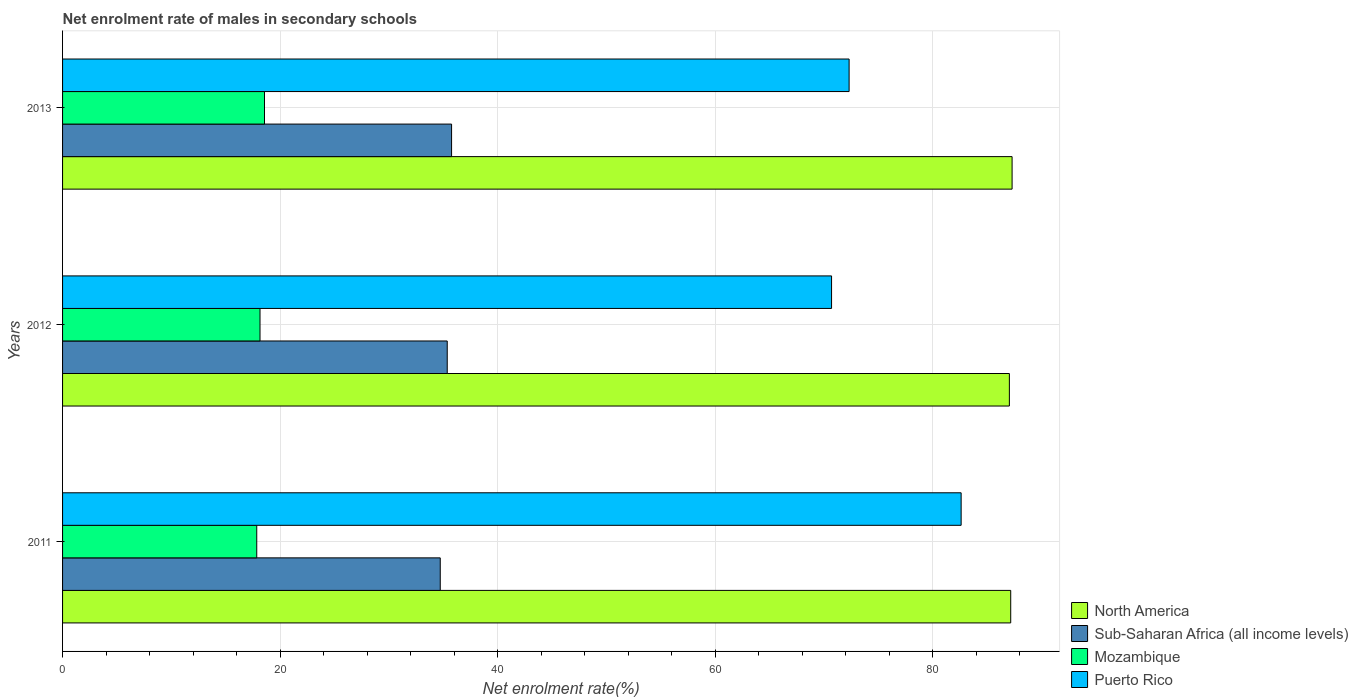Are the number of bars per tick equal to the number of legend labels?
Give a very brief answer. Yes. Are the number of bars on each tick of the Y-axis equal?
Make the answer very short. Yes. How many bars are there on the 2nd tick from the top?
Your response must be concise. 4. How many bars are there on the 3rd tick from the bottom?
Offer a very short reply. 4. In how many cases, is the number of bars for a given year not equal to the number of legend labels?
Your answer should be compact. 0. What is the net enrolment rate of males in secondary schools in Puerto Rico in 2013?
Keep it short and to the point. 72.31. Across all years, what is the maximum net enrolment rate of males in secondary schools in Sub-Saharan Africa (all income levels)?
Give a very brief answer. 35.76. Across all years, what is the minimum net enrolment rate of males in secondary schools in North America?
Keep it short and to the point. 87.04. What is the total net enrolment rate of males in secondary schools in Puerto Rico in the graph?
Keep it short and to the point. 225.6. What is the difference between the net enrolment rate of males in secondary schools in Puerto Rico in 2011 and that in 2012?
Make the answer very short. 11.91. What is the difference between the net enrolment rate of males in secondary schools in Mozambique in 2013 and the net enrolment rate of males in secondary schools in North America in 2012?
Your answer should be compact. -68.47. What is the average net enrolment rate of males in secondary schools in Sub-Saharan Africa (all income levels) per year?
Your answer should be compact. 35.28. In the year 2013, what is the difference between the net enrolment rate of males in secondary schools in North America and net enrolment rate of males in secondary schools in Mozambique?
Offer a terse response. 68.72. In how many years, is the net enrolment rate of males in secondary schools in North America greater than 8 %?
Keep it short and to the point. 3. What is the ratio of the net enrolment rate of males in secondary schools in North America in 2011 to that in 2013?
Your response must be concise. 1. Is the net enrolment rate of males in secondary schools in Puerto Rico in 2012 less than that in 2013?
Ensure brevity in your answer.  Yes. Is the difference between the net enrolment rate of males in secondary schools in North America in 2011 and 2013 greater than the difference between the net enrolment rate of males in secondary schools in Mozambique in 2011 and 2013?
Offer a very short reply. Yes. What is the difference between the highest and the second highest net enrolment rate of males in secondary schools in Sub-Saharan Africa (all income levels)?
Make the answer very short. 0.4. What is the difference between the highest and the lowest net enrolment rate of males in secondary schools in Mozambique?
Provide a succinct answer. 0.71. In how many years, is the net enrolment rate of males in secondary schools in North America greater than the average net enrolment rate of males in secondary schools in North America taken over all years?
Make the answer very short. 1. Is it the case that in every year, the sum of the net enrolment rate of males in secondary schools in Sub-Saharan Africa (all income levels) and net enrolment rate of males in secondary schools in North America is greater than the sum of net enrolment rate of males in secondary schools in Mozambique and net enrolment rate of males in secondary schools in Puerto Rico?
Provide a short and direct response. Yes. What does the 3rd bar from the top in 2012 represents?
Give a very brief answer. Sub-Saharan Africa (all income levels). What does the 4th bar from the bottom in 2011 represents?
Offer a very short reply. Puerto Rico. Are all the bars in the graph horizontal?
Your response must be concise. Yes. Are the values on the major ticks of X-axis written in scientific E-notation?
Offer a terse response. No. Does the graph contain any zero values?
Provide a succinct answer. No. Does the graph contain grids?
Give a very brief answer. Yes. How are the legend labels stacked?
Your answer should be compact. Vertical. What is the title of the graph?
Your answer should be very brief. Net enrolment rate of males in secondary schools. What is the label or title of the X-axis?
Keep it short and to the point. Net enrolment rate(%). What is the label or title of the Y-axis?
Offer a very short reply. Years. What is the Net enrolment rate(%) of North America in 2011?
Ensure brevity in your answer.  87.16. What is the Net enrolment rate(%) of Sub-Saharan Africa (all income levels) in 2011?
Your answer should be very brief. 34.72. What is the Net enrolment rate(%) in Mozambique in 2011?
Provide a short and direct response. 17.85. What is the Net enrolment rate(%) of Puerto Rico in 2011?
Offer a terse response. 82.6. What is the Net enrolment rate(%) in North America in 2012?
Your response must be concise. 87.04. What is the Net enrolment rate(%) in Sub-Saharan Africa (all income levels) in 2012?
Keep it short and to the point. 35.36. What is the Net enrolment rate(%) in Mozambique in 2012?
Offer a terse response. 18.15. What is the Net enrolment rate(%) in Puerto Rico in 2012?
Offer a terse response. 70.69. What is the Net enrolment rate(%) of North America in 2013?
Make the answer very short. 87.29. What is the Net enrolment rate(%) of Sub-Saharan Africa (all income levels) in 2013?
Your response must be concise. 35.76. What is the Net enrolment rate(%) in Mozambique in 2013?
Keep it short and to the point. 18.56. What is the Net enrolment rate(%) of Puerto Rico in 2013?
Your response must be concise. 72.31. Across all years, what is the maximum Net enrolment rate(%) of North America?
Provide a short and direct response. 87.29. Across all years, what is the maximum Net enrolment rate(%) of Sub-Saharan Africa (all income levels)?
Your response must be concise. 35.76. Across all years, what is the maximum Net enrolment rate(%) in Mozambique?
Your answer should be very brief. 18.56. Across all years, what is the maximum Net enrolment rate(%) in Puerto Rico?
Provide a succinct answer. 82.6. Across all years, what is the minimum Net enrolment rate(%) of North America?
Your response must be concise. 87.04. Across all years, what is the minimum Net enrolment rate(%) in Sub-Saharan Africa (all income levels)?
Provide a succinct answer. 34.72. Across all years, what is the minimum Net enrolment rate(%) in Mozambique?
Your answer should be compact. 17.85. Across all years, what is the minimum Net enrolment rate(%) of Puerto Rico?
Offer a terse response. 70.69. What is the total Net enrolment rate(%) of North America in the graph?
Your answer should be compact. 261.49. What is the total Net enrolment rate(%) of Sub-Saharan Africa (all income levels) in the graph?
Offer a very short reply. 105.84. What is the total Net enrolment rate(%) of Mozambique in the graph?
Provide a succinct answer. 54.57. What is the total Net enrolment rate(%) of Puerto Rico in the graph?
Keep it short and to the point. 225.6. What is the difference between the Net enrolment rate(%) of North America in 2011 and that in 2012?
Your response must be concise. 0.12. What is the difference between the Net enrolment rate(%) in Sub-Saharan Africa (all income levels) in 2011 and that in 2012?
Your response must be concise. -0.64. What is the difference between the Net enrolment rate(%) of Mozambique in 2011 and that in 2012?
Offer a very short reply. -0.3. What is the difference between the Net enrolment rate(%) in Puerto Rico in 2011 and that in 2012?
Your answer should be very brief. 11.91. What is the difference between the Net enrolment rate(%) in North America in 2011 and that in 2013?
Your answer should be compact. -0.13. What is the difference between the Net enrolment rate(%) of Sub-Saharan Africa (all income levels) in 2011 and that in 2013?
Your answer should be compact. -1.04. What is the difference between the Net enrolment rate(%) in Mozambique in 2011 and that in 2013?
Give a very brief answer. -0.71. What is the difference between the Net enrolment rate(%) in Puerto Rico in 2011 and that in 2013?
Keep it short and to the point. 10.3. What is the difference between the Net enrolment rate(%) of North America in 2012 and that in 2013?
Provide a succinct answer. -0.25. What is the difference between the Net enrolment rate(%) of Sub-Saharan Africa (all income levels) in 2012 and that in 2013?
Make the answer very short. -0.4. What is the difference between the Net enrolment rate(%) of Mozambique in 2012 and that in 2013?
Keep it short and to the point. -0.41. What is the difference between the Net enrolment rate(%) of Puerto Rico in 2012 and that in 2013?
Your answer should be very brief. -1.61. What is the difference between the Net enrolment rate(%) in North America in 2011 and the Net enrolment rate(%) in Sub-Saharan Africa (all income levels) in 2012?
Your response must be concise. 51.8. What is the difference between the Net enrolment rate(%) of North America in 2011 and the Net enrolment rate(%) of Mozambique in 2012?
Make the answer very short. 69.01. What is the difference between the Net enrolment rate(%) of North America in 2011 and the Net enrolment rate(%) of Puerto Rico in 2012?
Offer a very short reply. 16.47. What is the difference between the Net enrolment rate(%) in Sub-Saharan Africa (all income levels) in 2011 and the Net enrolment rate(%) in Mozambique in 2012?
Give a very brief answer. 16.57. What is the difference between the Net enrolment rate(%) in Sub-Saharan Africa (all income levels) in 2011 and the Net enrolment rate(%) in Puerto Rico in 2012?
Keep it short and to the point. -35.97. What is the difference between the Net enrolment rate(%) in Mozambique in 2011 and the Net enrolment rate(%) in Puerto Rico in 2012?
Provide a short and direct response. -52.84. What is the difference between the Net enrolment rate(%) of North America in 2011 and the Net enrolment rate(%) of Sub-Saharan Africa (all income levels) in 2013?
Provide a succinct answer. 51.4. What is the difference between the Net enrolment rate(%) in North America in 2011 and the Net enrolment rate(%) in Mozambique in 2013?
Ensure brevity in your answer.  68.6. What is the difference between the Net enrolment rate(%) of North America in 2011 and the Net enrolment rate(%) of Puerto Rico in 2013?
Your response must be concise. 14.86. What is the difference between the Net enrolment rate(%) in Sub-Saharan Africa (all income levels) in 2011 and the Net enrolment rate(%) in Mozambique in 2013?
Your answer should be very brief. 16.16. What is the difference between the Net enrolment rate(%) of Sub-Saharan Africa (all income levels) in 2011 and the Net enrolment rate(%) of Puerto Rico in 2013?
Your response must be concise. -37.59. What is the difference between the Net enrolment rate(%) in Mozambique in 2011 and the Net enrolment rate(%) in Puerto Rico in 2013?
Provide a succinct answer. -54.45. What is the difference between the Net enrolment rate(%) in North America in 2012 and the Net enrolment rate(%) in Sub-Saharan Africa (all income levels) in 2013?
Make the answer very short. 51.28. What is the difference between the Net enrolment rate(%) of North America in 2012 and the Net enrolment rate(%) of Mozambique in 2013?
Provide a short and direct response. 68.47. What is the difference between the Net enrolment rate(%) of North America in 2012 and the Net enrolment rate(%) of Puerto Rico in 2013?
Offer a terse response. 14.73. What is the difference between the Net enrolment rate(%) of Sub-Saharan Africa (all income levels) in 2012 and the Net enrolment rate(%) of Mozambique in 2013?
Your answer should be very brief. 16.8. What is the difference between the Net enrolment rate(%) of Sub-Saharan Africa (all income levels) in 2012 and the Net enrolment rate(%) of Puerto Rico in 2013?
Ensure brevity in your answer.  -36.94. What is the difference between the Net enrolment rate(%) of Mozambique in 2012 and the Net enrolment rate(%) of Puerto Rico in 2013?
Provide a succinct answer. -54.15. What is the average Net enrolment rate(%) in North America per year?
Ensure brevity in your answer.  87.16. What is the average Net enrolment rate(%) in Sub-Saharan Africa (all income levels) per year?
Your answer should be compact. 35.28. What is the average Net enrolment rate(%) of Mozambique per year?
Offer a terse response. 18.19. What is the average Net enrolment rate(%) in Puerto Rico per year?
Provide a short and direct response. 75.2. In the year 2011, what is the difference between the Net enrolment rate(%) in North America and Net enrolment rate(%) in Sub-Saharan Africa (all income levels)?
Make the answer very short. 52.44. In the year 2011, what is the difference between the Net enrolment rate(%) in North America and Net enrolment rate(%) in Mozambique?
Your answer should be very brief. 69.31. In the year 2011, what is the difference between the Net enrolment rate(%) in North America and Net enrolment rate(%) in Puerto Rico?
Offer a very short reply. 4.56. In the year 2011, what is the difference between the Net enrolment rate(%) of Sub-Saharan Africa (all income levels) and Net enrolment rate(%) of Mozambique?
Your answer should be compact. 16.87. In the year 2011, what is the difference between the Net enrolment rate(%) of Sub-Saharan Africa (all income levels) and Net enrolment rate(%) of Puerto Rico?
Provide a succinct answer. -47.88. In the year 2011, what is the difference between the Net enrolment rate(%) in Mozambique and Net enrolment rate(%) in Puerto Rico?
Provide a succinct answer. -64.75. In the year 2012, what is the difference between the Net enrolment rate(%) of North America and Net enrolment rate(%) of Sub-Saharan Africa (all income levels)?
Your answer should be very brief. 51.68. In the year 2012, what is the difference between the Net enrolment rate(%) in North America and Net enrolment rate(%) in Mozambique?
Make the answer very short. 68.89. In the year 2012, what is the difference between the Net enrolment rate(%) of North America and Net enrolment rate(%) of Puerto Rico?
Make the answer very short. 16.35. In the year 2012, what is the difference between the Net enrolment rate(%) of Sub-Saharan Africa (all income levels) and Net enrolment rate(%) of Mozambique?
Offer a very short reply. 17.21. In the year 2012, what is the difference between the Net enrolment rate(%) of Sub-Saharan Africa (all income levels) and Net enrolment rate(%) of Puerto Rico?
Give a very brief answer. -35.33. In the year 2012, what is the difference between the Net enrolment rate(%) in Mozambique and Net enrolment rate(%) in Puerto Rico?
Provide a short and direct response. -52.54. In the year 2013, what is the difference between the Net enrolment rate(%) of North America and Net enrolment rate(%) of Sub-Saharan Africa (all income levels)?
Provide a short and direct response. 51.53. In the year 2013, what is the difference between the Net enrolment rate(%) in North America and Net enrolment rate(%) in Mozambique?
Your response must be concise. 68.72. In the year 2013, what is the difference between the Net enrolment rate(%) of North America and Net enrolment rate(%) of Puerto Rico?
Your answer should be compact. 14.98. In the year 2013, what is the difference between the Net enrolment rate(%) in Sub-Saharan Africa (all income levels) and Net enrolment rate(%) in Mozambique?
Provide a succinct answer. 17.2. In the year 2013, what is the difference between the Net enrolment rate(%) of Sub-Saharan Africa (all income levels) and Net enrolment rate(%) of Puerto Rico?
Offer a terse response. -36.54. In the year 2013, what is the difference between the Net enrolment rate(%) of Mozambique and Net enrolment rate(%) of Puerto Rico?
Offer a terse response. -53.74. What is the ratio of the Net enrolment rate(%) in North America in 2011 to that in 2012?
Provide a succinct answer. 1. What is the ratio of the Net enrolment rate(%) of Sub-Saharan Africa (all income levels) in 2011 to that in 2012?
Give a very brief answer. 0.98. What is the ratio of the Net enrolment rate(%) in Mozambique in 2011 to that in 2012?
Keep it short and to the point. 0.98. What is the ratio of the Net enrolment rate(%) in Puerto Rico in 2011 to that in 2012?
Offer a terse response. 1.17. What is the ratio of the Net enrolment rate(%) in North America in 2011 to that in 2013?
Give a very brief answer. 1. What is the ratio of the Net enrolment rate(%) of Sub-Saharan Africa (all income levels) in 2011 to that in 2013?
Ensure brevity in your answer.  0.97. What is the ratio of the Net enrolment rate(%) of Mozambique in 2011 to that in 2013?
Keep it short and to the point. 0.96. What is the ratio of the Net enrolment rate(%) in Puerto Rico in 2011 to that in 2013?
Make the answer very short. 1.14. What is the ratio of the Net enrolment rate(%) in Mozambique in 2012 to that in 2013?
Provide a short and direct response. 0.98. What is the ratio of the Net enrolment rate(%) of Puerto Rico in 2012 to that in 2013?
Your response must be concise. 0.98. What is the difference between the highest and the second highest Net enrolment rate(%) of North America?
Your response must be concise. 0.13. What is the difference between the highest and the second highest Net enrolment rate(%) of Sub-Saharan Africa (all income levels)?
Give a very brief answer. 0.4. What is the difference between the highest and the second highest Net enrolment rate(%) of Mozambique?
Provide a short and direct response. 0.41. What is the difference between the highest and the second highest Net enrolment rate(%) of Puerto Rico?
Ensure brevity in your answer.  10.3. What is the difference between the highest and the lowest Net enrolment rate(%) of North America?
Provide a short and direct response. 0.25. What is the difference between the highest and the lowest Net enrolment rate(%) in Sub-Saharan Africa (all income levels)?
Keep it short and to the point. 1.04. What is the difference between the highest and the lowest Net enrolment rate(%) in Mozambique?
Give a very brief answer. 0.71. What is the difference between the highest and the lowest Net enrolment rate(%) in Puerto Rico?
Offer a very short reply. 11.91. 